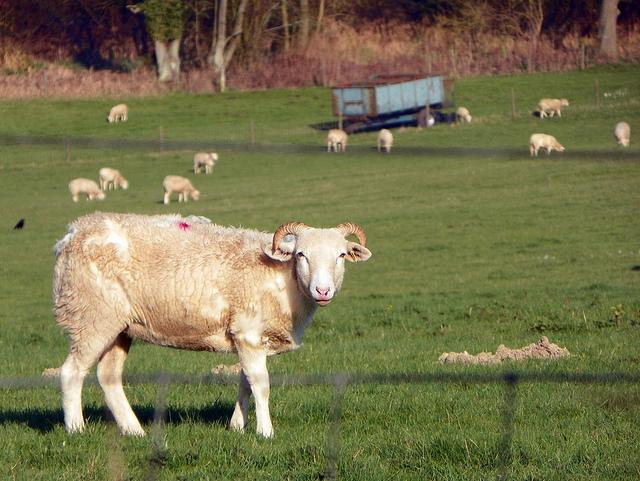Why do sheep have horns?

Choices:
A) nothing
B) playing
C) mating
D) shock-absorbers shock-absorbers 